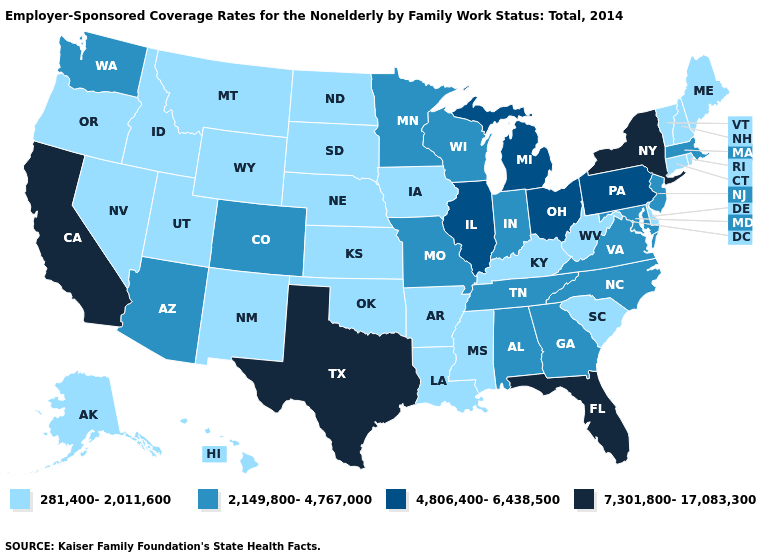Name the states that have a value in the range 4,806,400-6,438,500?
Quick response, please. Illinois, Michigan, Ohio, Pennsylvania. What is the value of Nebraska?
Write a very short answer. 281,400-2,011,600. What is the value of Arkansas?
Keep it brief. 281,400-2,011,600. Does New Jersey have the lowest value in the USA?
Short answer required. No. Does the map have missing data?
Short answer required. No. Does the map have missing data?
Answer briefly. No. Which states have the highest value in the USA?
Keep it brief. California, Florida, New York, Texas. What is the value of Rhode Island?
Short answer required. 281,400-2,011,600. Name the states that have a value in the range 7,301,800-17,083,300?
Write a very short answer. California, Florida, New York, Texas. What is the lowest value in the USA?
Write a very short answer. 281,400-2,011,600. What is the value of Oklahoma?
Be succinct. 281,400-2,011,600. Does the first symbol in the legend represent the smallest category?
Keep it brief. Yes. Name the states that have a value in the range 7,301,800-17,083,300?
Be succinct. California, Florida, New York, Texas. What is the highest value in the MidWest ?
Concise answer only. 4,806,400-6,438,500. 